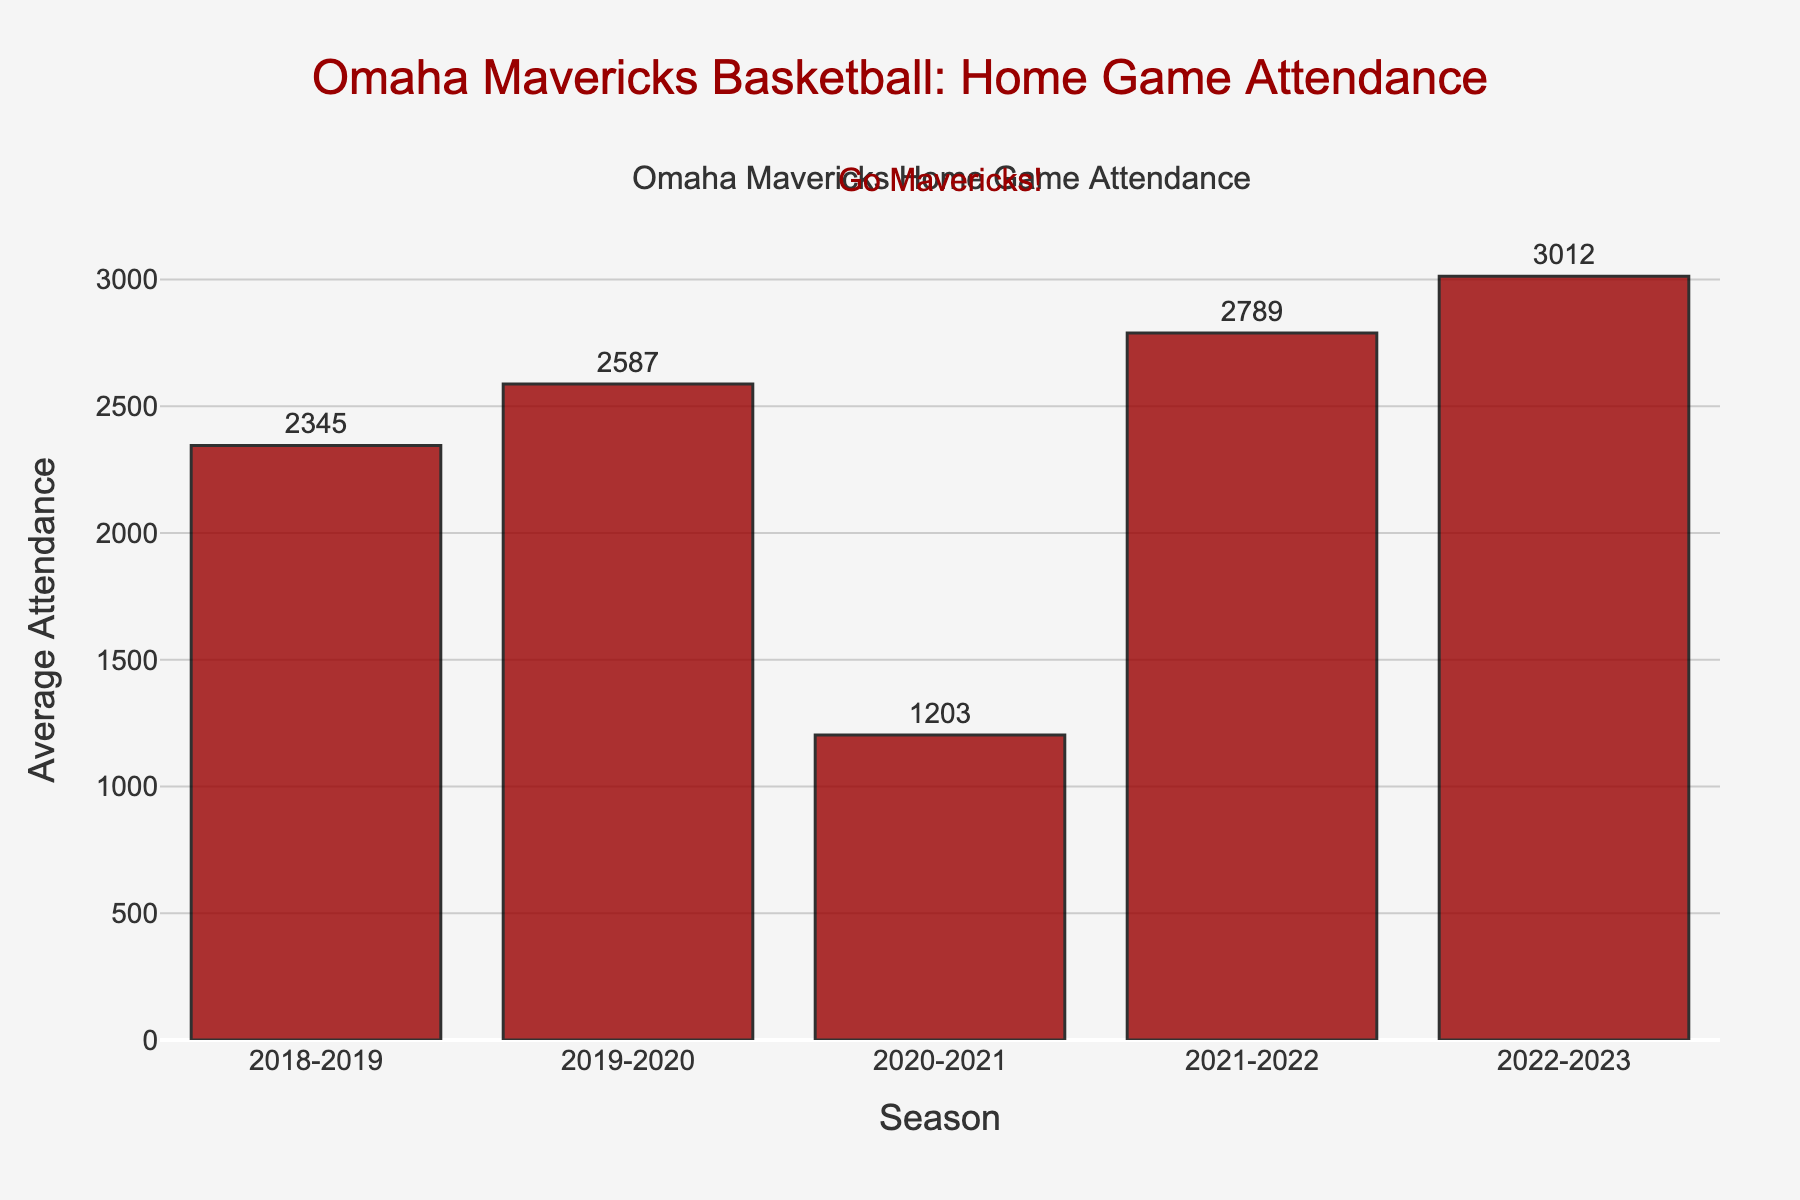What's the average attendance during the 2022-2023 season? The bar corresponding to the 2022-2023 season shows a value of 3012.
Answer: 3012 Which season had the lowest average attendance? By observing the heights of the bars, the 2020-2021 season has the shortest bar, indicating the lowest average attendance of 1203.
Answer: 2020-2021 How much did the average attendance increase from the 2020-2021 season to the 2021-2022 season? The average attendance for 2020-2021 is 1203, and for 2021-2022 is 2789. The increase is 2789 - 1203 = 1586.
Answer: 1586 What is the range of average attendance values across the seasons? The maximum average attendance is in the 2022-2023 season with 3012, and the minimum is in the 2020-2021 season with 1203. The range is 3012 - 1203 = 1809.
Answer: 1809 Which seasons have an average attendance greater than 2500? Observing the bars, the seasons 2019-2020, 2021-2022, and 2022-2023 have average attendances greater than 2500.
Answer: 2019-2020, 2021-2022, 2022-2023 Calculate the average attendance over the five seasons. The total attendance over five seasons is 2345 + 2587 + 1203 + 2789 + 3012 = 11936. Dividing by 5 gives 11936 / 5 = 2387.2.
Answer: 2387.2 Did the average attendance show an overall increasing or decreasing trend? Comparing initial and final data points, attendance started at 2345 in 2018-2019 and increased to 3012 in 2022-2023, demonstrating an overall increasing trend despite fluctuations.
Answer: Increasing Which two consecutive seasons show the greatest increase in average attendance? Comparing differences, the increases for consecutive seasons are: 2018-2019 to 2019-2020 (242), 2019-2020 to 2020-2021 (-1384), 2020-2021 to 2021-2022 (1586), and 2021-2022 to 2022-2023 (223). The greatest increase is from 2020-2021 to 2021-2022 (1586).
Answer: 2020-2021 to 2021-2022 What is the combined average attendance for the years with attendances lower than 2500? The seasons 2018-2019 and 2020-2021 have attendances lower than 2500. Combined attendance is 2345 + 1203 = 3548, and there are two such seasons, so 3548 / 2 = 1774.
Answer: 1774 